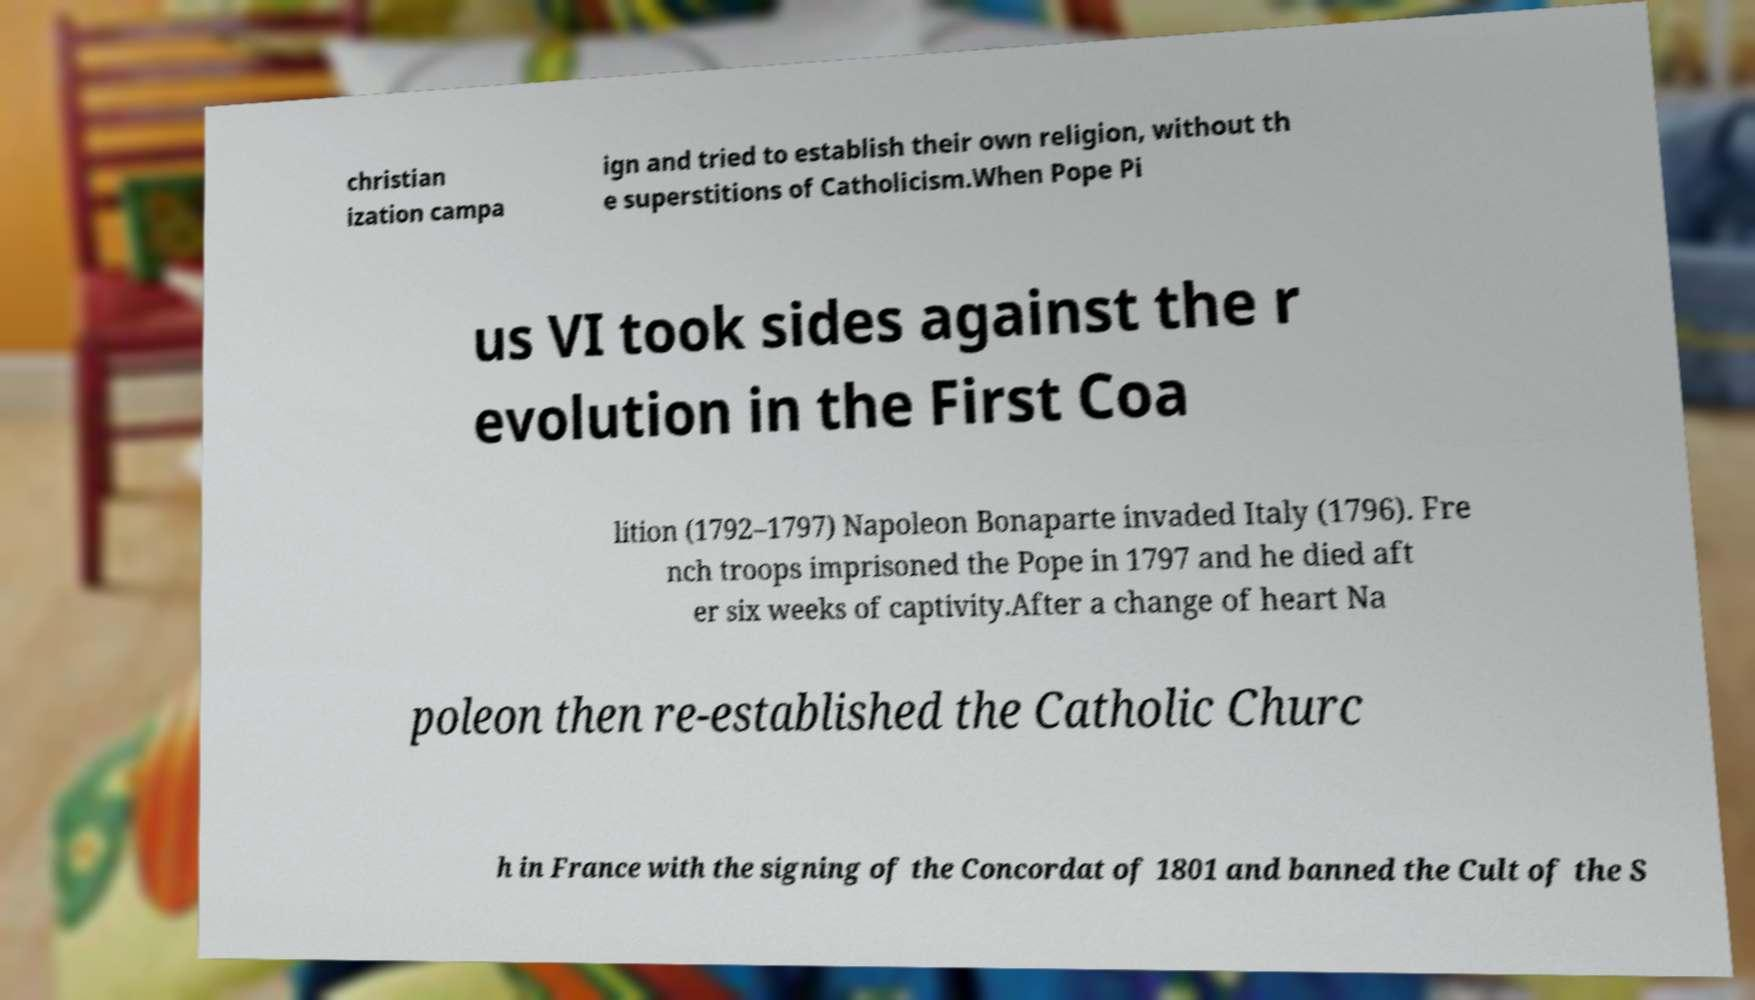I need the written content from this picture converted into text. Can you do that? christian ization campa ign and tried to establish their own religion, without th e superstitions of Catholicism.When Pope Pi us VI took sides against the r evolution in the First Coa lition (1792–1797) Napoleon Bonaparte invaded Italy (1796). Fre nch troops imprisoned the Pope in 1797 and he died aft er six weeks of captivity.After a change of heart Na poleon then re-established the Catholic Churc h in France with the signing of the Concordat of 1801 and banned the Cult of the S 